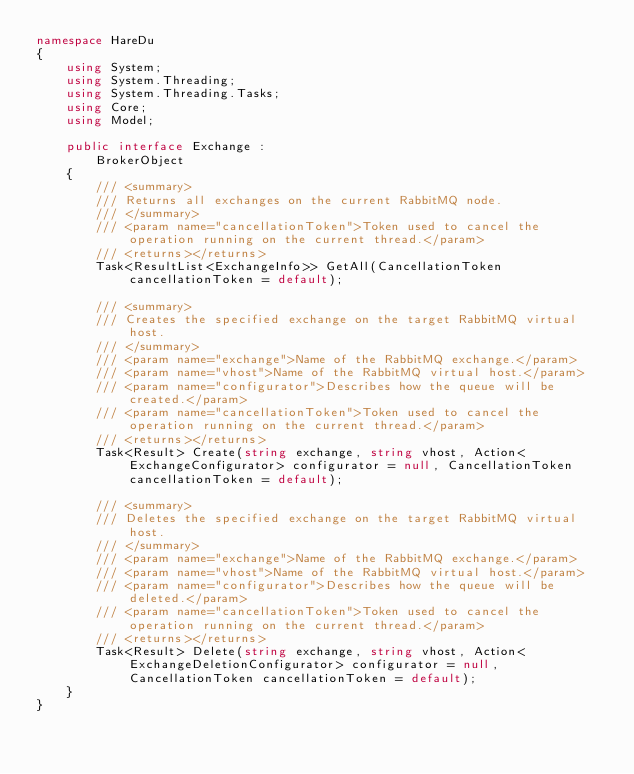<code> <loc_0><loc_0><loc_500><loc_500><_C#_>namespace HareDu
{
    using System;
    using System.Threading;
    using System.Threading.Tasks;
    using Core;
    using Model;

    public interface Exchange :
        BrokerObject
    {
        /// <summary>
        /// Returns all exchanges on the current RabbitMQ node.
        /// </summary>
        /// <param name="cancellationToken">Token used to cancel the operation running on the current thread.</param>
        /// <returns></returns>
        Task<ResultList<ExchangeInfo>> GetAll(CancellationToken cancellationToken = default);

        /// <summary>
        /// Creates the specified exchange on the target RabbitMQ virtual host.
        /// </summary>
        /// <param name="exchange">Name of the RabbitMQ exchange.</param>
        /// <param name="vhost">Name of the RabbitMQ virtual host.</param>
        /// <param name="configurator">Describes how the queue will be created.</param>
        /// <param name="cancellationToken">Token used to cancel the operation running on the current thread.</param>
        /// <returns></returns>
        Task<Result> Create(string exchange, string vhost, Action<ExchangeConfigurator> configurator = null, CancellationToken cancellationToken = default);

        /// <summary>
        /// Deletes the specified exchange on the target RabbitMQ virtual host.
        /// </summary>
        /// <param name="exchange">Name of the RabbitMQ exchange.</param>
        /// <param name="vhost">Name of the RabbitMQ virtual host.</param>
        /// <param name="configurator">Describes how the queue will be deleted.</param>
        /// <param name="cancellationToken">Token used to cancel the operation running on the current thread.</param>
        /// <returns></returns>
        Task<Result> Delete(string exchange, string vhost, Action<ExchangeDeletionConfigurator> configurator = null, CancellationToken cancellationToken = default);
    }
}</code> 